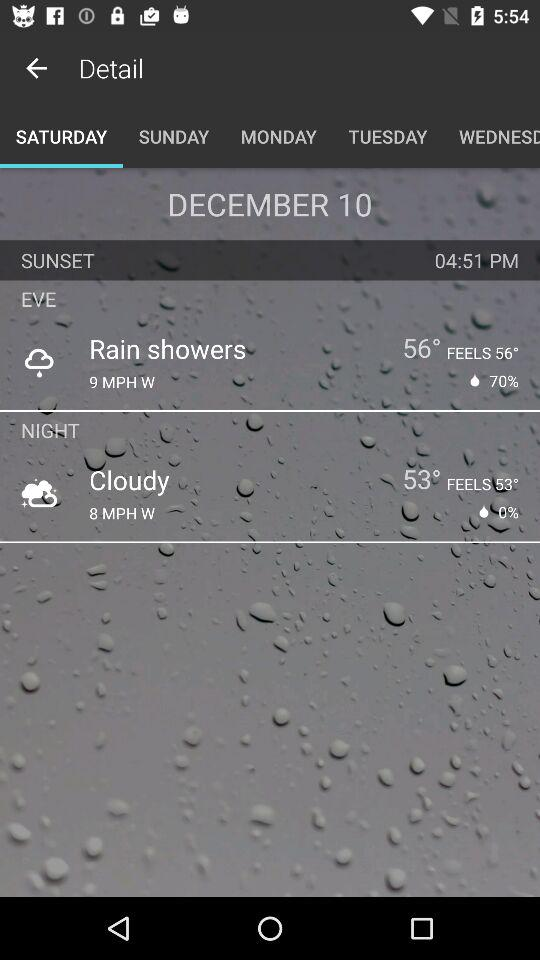What is the temperature at night? The temperature at night is 53 degrees. 